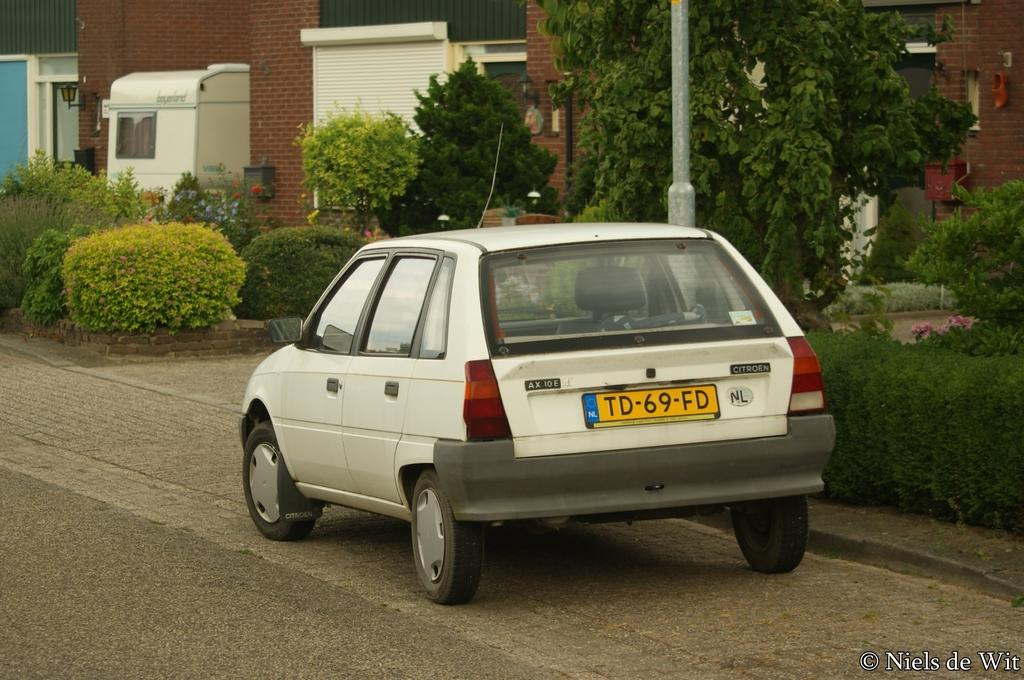What is on the road in the image? There is a car on the road in the image. What type of structure can be seen in the image? There is a house in the image. What can be seen illuminated in the image? There are lights visible in the image. What type of vegetation is present in the image? There are plants and trees in the image. Can you tell me how many basketballs are lying on the ground near the car in the image? There are no basketballs present in the image. What type of bun is sitting on the roof of the house in the image? There is no bun present in the image. 